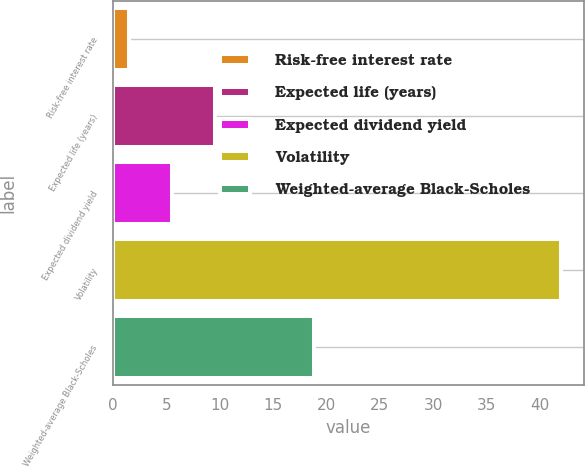<chart> <loc_0><loc_0><loc_500><loc_500><bar_chart><fcel>Risk-free interest rate<fcel>Expected life (years)<fcel>Expected dividend yield<fcel>Volatility<fcel>Weighted-average Black-Scholes<nl><fcel>1.5<fcel>9.6<fcel>5.55<fcel>42<fcel>18.85<nl></chart> 